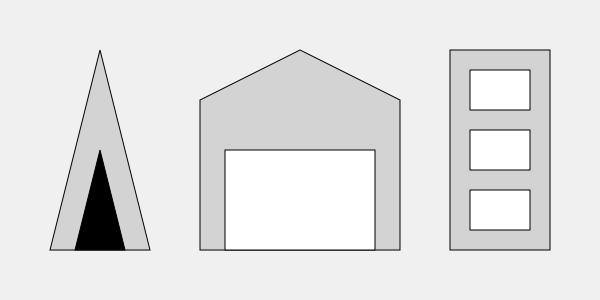Identify the architectural styles represented by the three building silhouettes from left to right. Let's analyze each silhouette from left to right:

1. The leftmost silhouette shows a tall, pointed structure with a triangular shape. This is characteristic of Gothic architecture, known for its emphasis on height and pointed arches. The smaller triangle within represents a typical Gothic window or door.

2. The middle silhouette displays a symmetrical structure with a triangular pediment on top of a rectangular base. This is indicative of Classical architecture, which often features columns (implied by the vertical lines) and a triangular pediment, inspired by ancient Greek and Roman temples.

3. The rightmost silhouette shows a simple, boxy structure with regular, repeating rectangular windows. This represents Modern architecture, characterized by its emphasis on function, clean lines, and lack of ornamentation.

These architectural styles span different historical periods and reflect the evolving aesthetics and technological capabilities in building design.
Answer: Gothic, Classical, Modern 